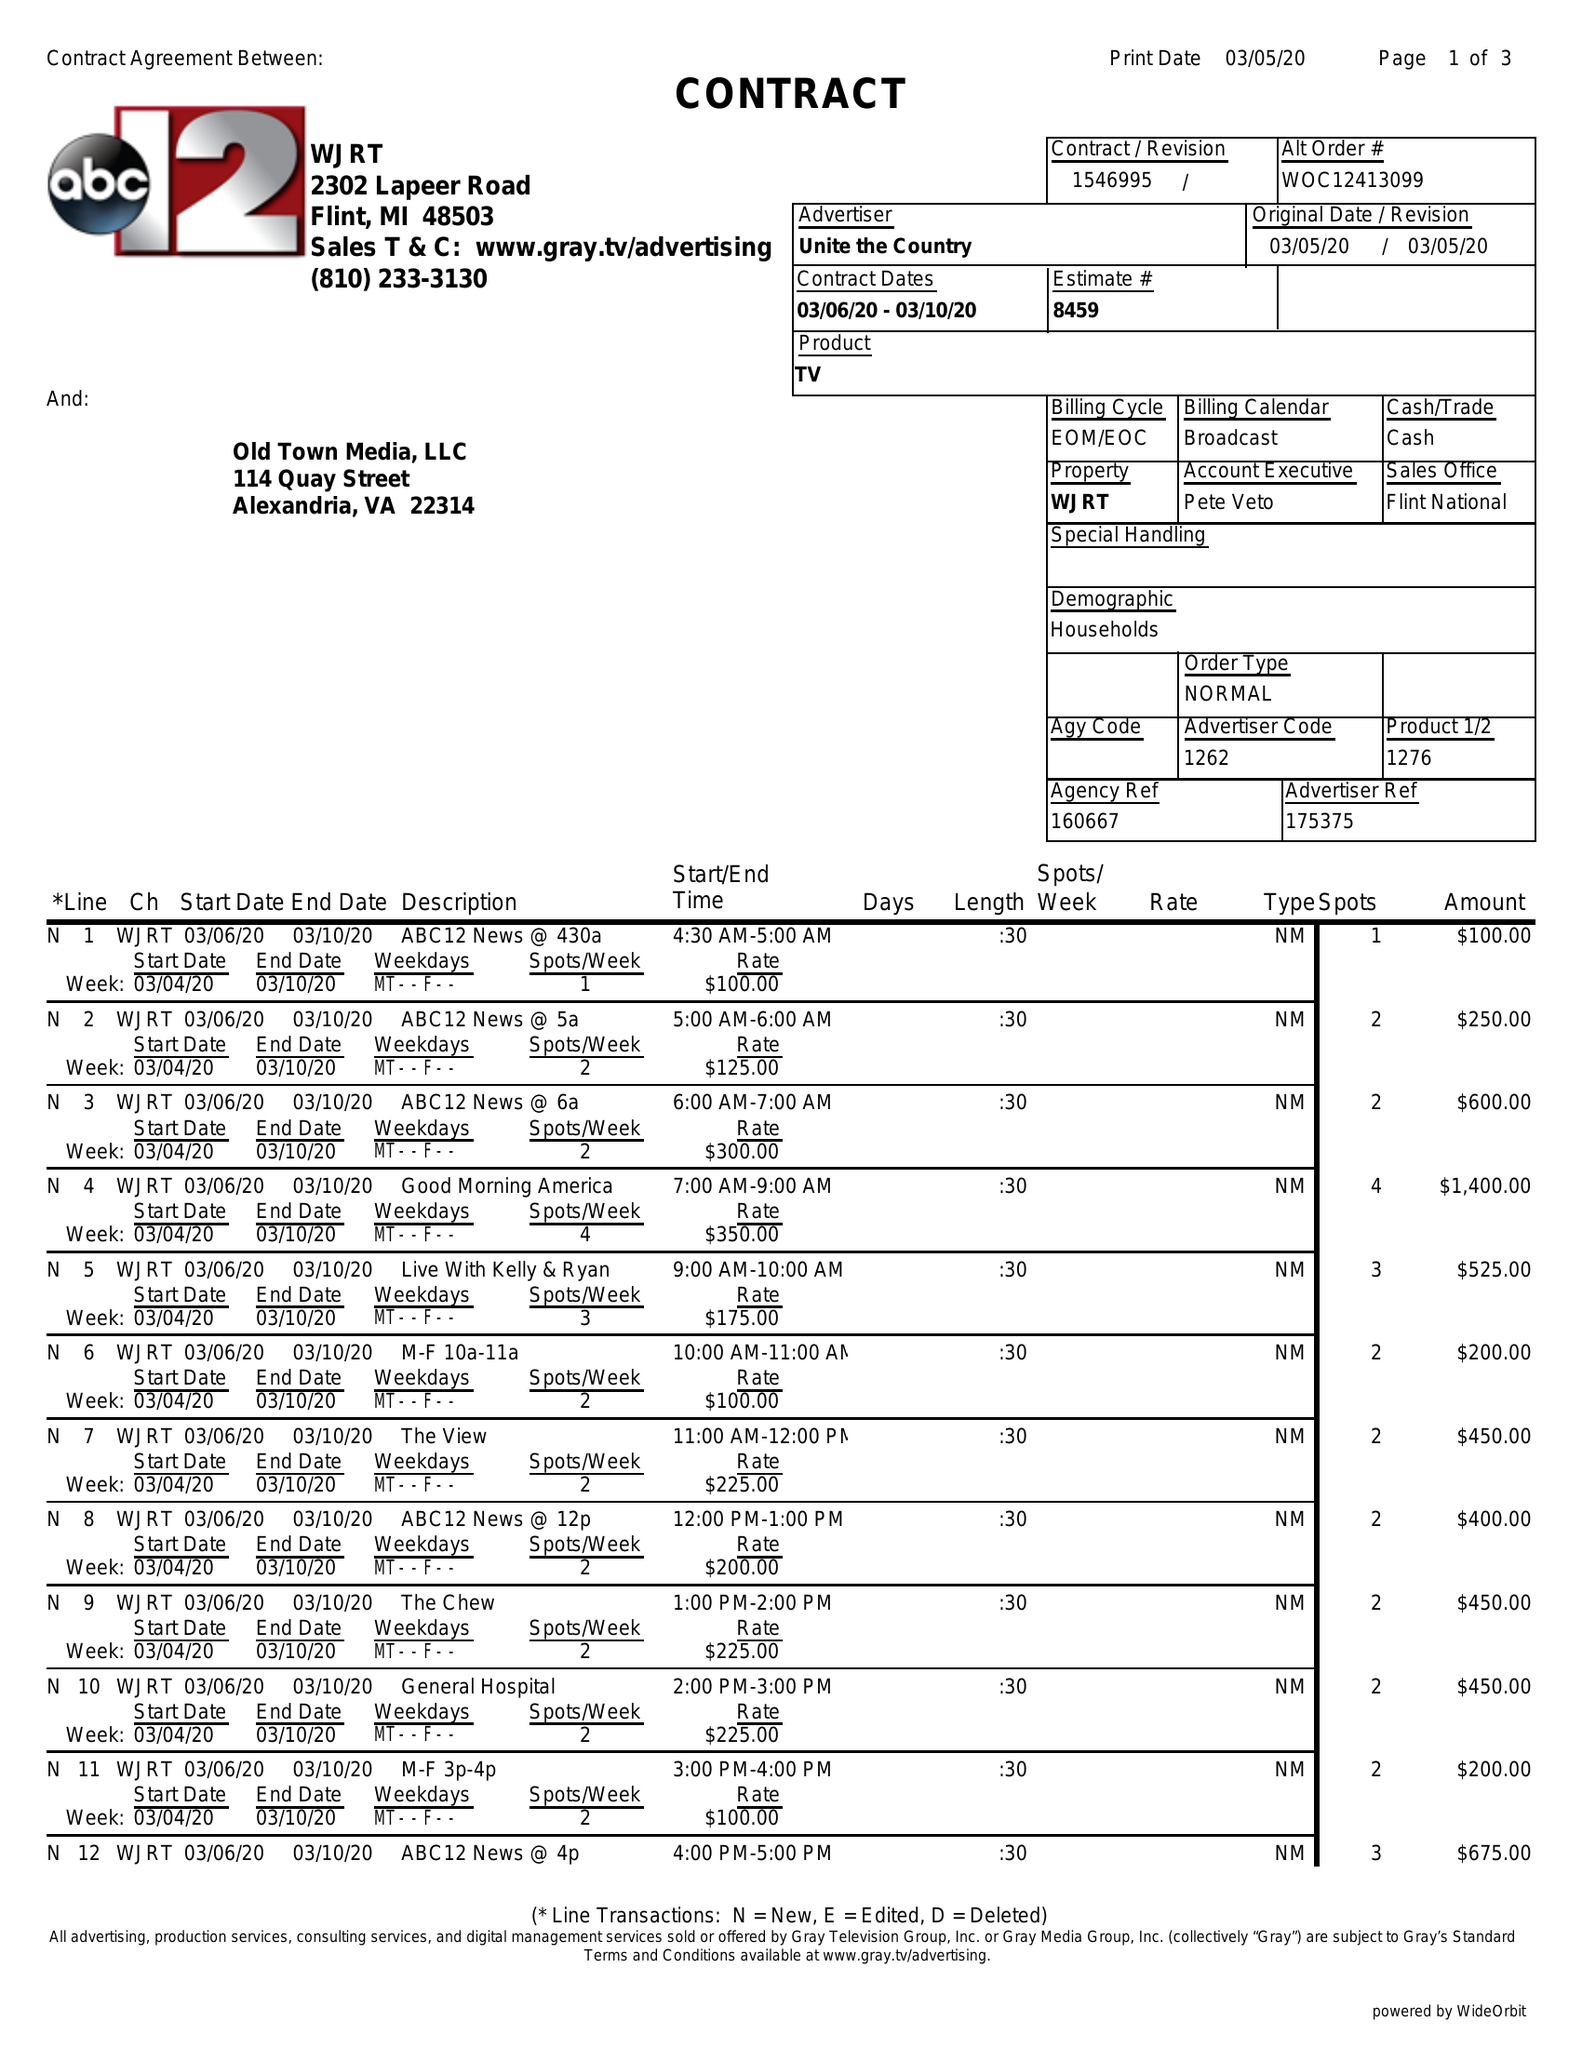What is the value for the flight_to?
Answer the question using a single word or phrase. 03/10/20 